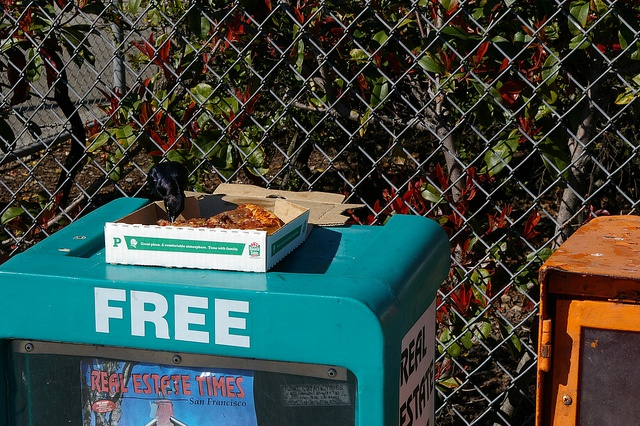Describe the objects in this image and their specific colors. I can see pizza in black, brown, and maroon tones and bird in black, gray, and darkblue tones in this image. 